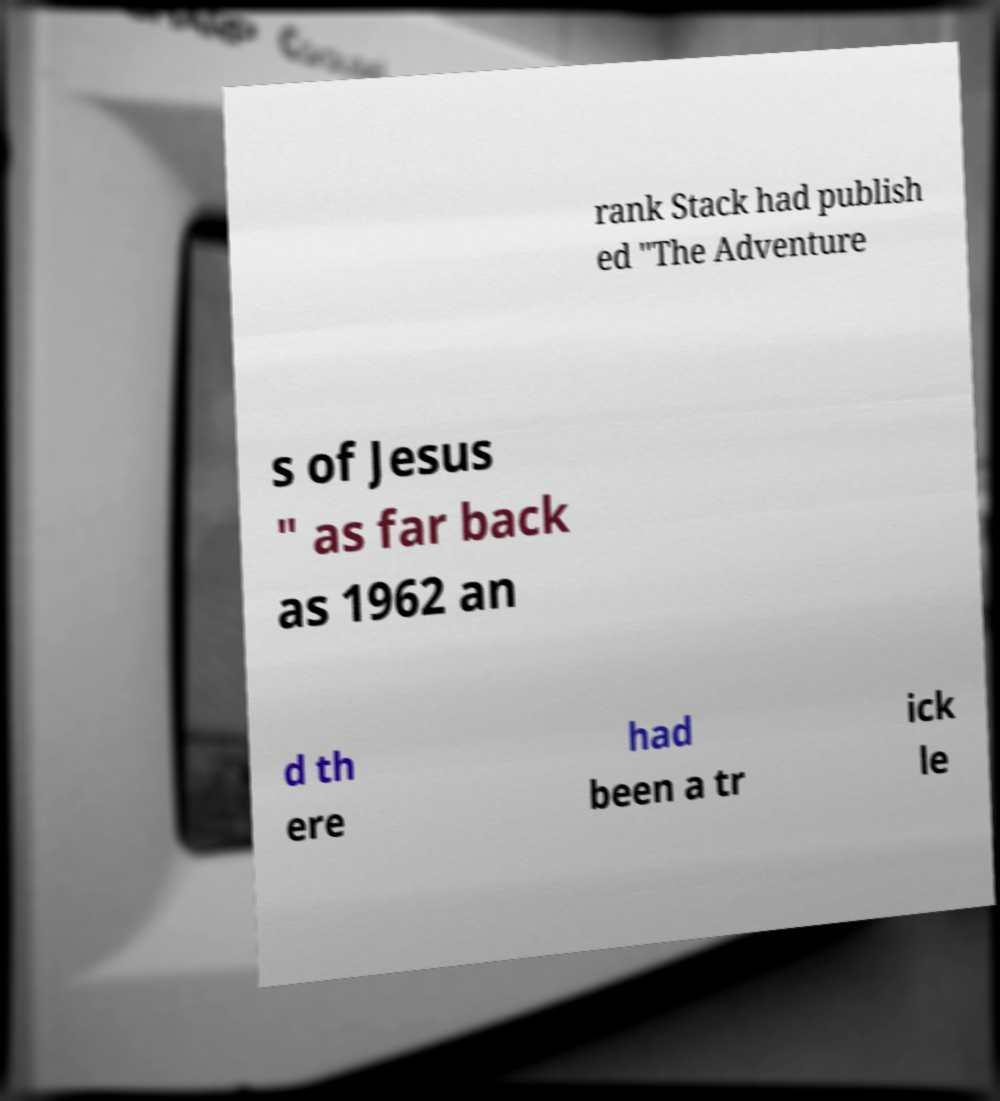Could you extract and type out the text from this image? rank Stack had publish ed "The Adventure s of Jesus " as far back as 1962 an d th ere had been a tr ick le 